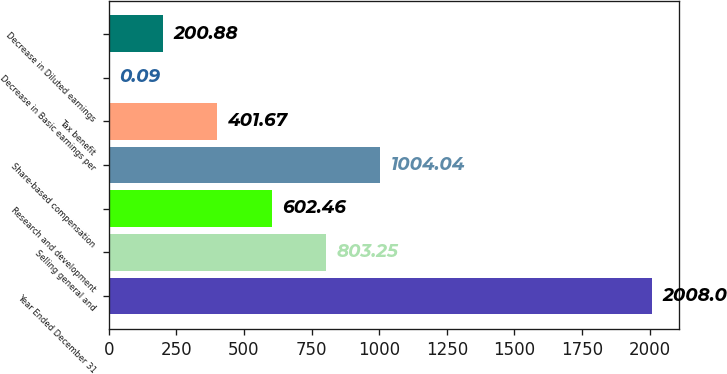Convert chart to OTSL. <chart><loc_0><loc_0><loc_500><loc_500><bar_chart><fcel>Year Ended December 31<fcel>Selling general and<fcel>Research and development<fcel>Share-based compensation<fcel>Tax benefit<fcel>Decrease in Basic earnings per<fcel>Decrease in Diluted earnings<nl><fcel>2008<fcel>803.25<fcel>602.46<fcel>1004.04<fcel>401.67<fcel>0.09<fcel>200.88<nl></chart> 